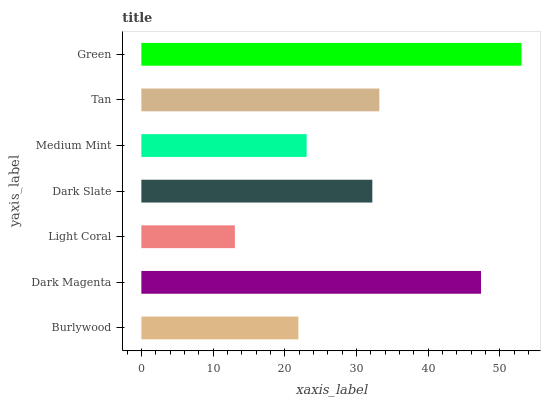Is Light Coral the minimum?
Answer yes or no. Yes. Is Green the maximum?
Answer yes or no. Yes. Is Dark Magenta the minimum?
Answer yes or no. No. Is Dark Magenta the maximum?
Answer yes or no. No. Is Dark Magenta greater than Burlywood?
Answer yes or no. Yes. Is Burlywood less than Dark Magenta?
Answer yes or no. Yes. Is Burlywood greater than Dark Magenta?
Answer yes or no. No. Is Dark Magenta less than Burlywood?
Answer yes or no. No. Is Dark Slate the high median?
Answer yes or no. Yes. Is Dark Slate the low median?
Answer yes or no. Yes. Is Medium Mint the high median?
Answer yes or no. No. Is Dark Magenta the low median?
Answer yes or no. No. 